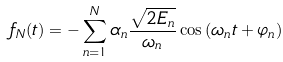Convert formula to latex. <formula><loc_0><loc_0><loc_500><loc_500>f _ { N } ( t ) = - \sum _ { n = 1 } ^ { N } \alpha _ { n } \frac { \sqrt { 2 E _ { n } } } { \omega _ { n } } \cos { ( \omega _ { n } t + \varphi _ { n } ) }</formula> 